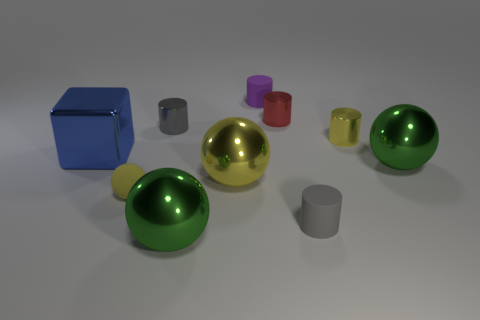Subtract all yellow cylinders. How many cylinders are left? 4 Subtract all purple rubber cylinders. How many cylinders are left? 4 Subtract all gray spheres. Subtract all gray cubes. How many spheres are left? 4 Subtract all balls. How many objects are left? 6 Add 2 gray shiny things. How many gray shiny things are left? 3 Add 1 matte cylinders. How many matte cylinders exist? 3 Subtract 0 green cubes. How many objects are left? 10 Subtract all gray shiny things. Subtract all small gray objects. How many objects are left? 7 